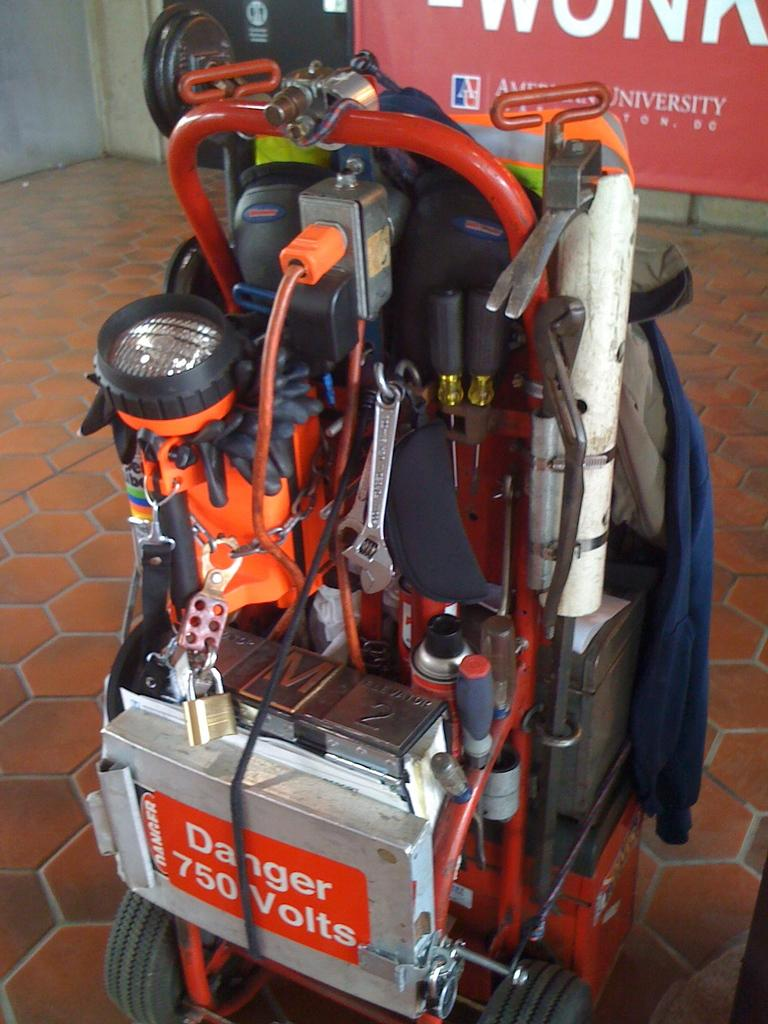What is the main object on the ground in the image? There is a machine on the ground in the image. What color is the banner behind the machine? There is a red color banner behind the machine. What type of structure can be seen in the image? There is a wall in the image. How many berries are hanging from the machine in the image? There are no berries present in the image; the main object is a machine. What type of beam is supporting the wall in the image? There is no beam visible in the image; only the wall is mentioned. 